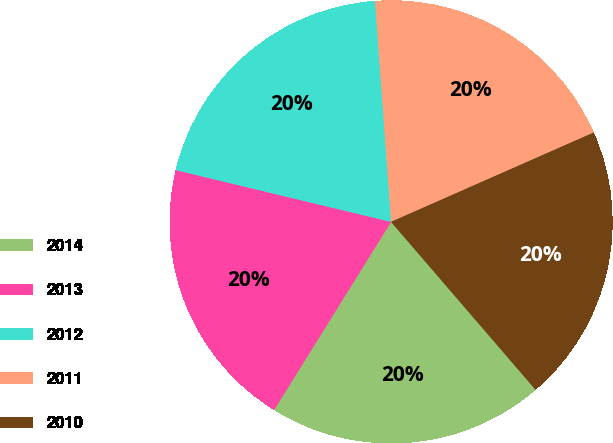Convert chart. <chart><loc_0><loc_0><loc_500><loc_500><pie_chart><fcel>2014<fcel>2013<fcel>2012<fcel>2011<fcel>2010<nl><fcel>20.17%<fcel>19.9%<fcel>20.09%<fcel>19.55%<fcel>20.3%<nl></chart> 